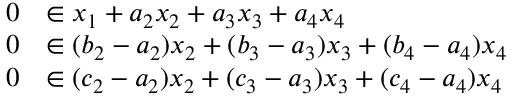Convert formula to latex. <formula><loc_0><loc_0><loc_500><loc_500>\begin{array} { r l } { 0 } & { \in x _ { 1 } + a _ { 2 } x _ { 2 } + a _ { 3 } x _ { 3 } + a _ { 4 } x _ { 4 } } \\ { 0 } & { \in ( b _ { 2 } - a _ { 2 } ) x _ { 2 } + ( b _ { 3 } - a _ { 3 } ) x _ { 3 } + ( b _ { 4 } - a _ { 4 } ) x _ { 4 } } \\ { 0 } & { \in ( c _ { 2 } - a _ { 2 } ) x _ { 2 } + ( c _ { 3 } - a _ { 3 } ) x _ { 3 } + ( c _ { 4 } - a _ { 4 } ) x _ { 4 } } \end{array}</formula> 